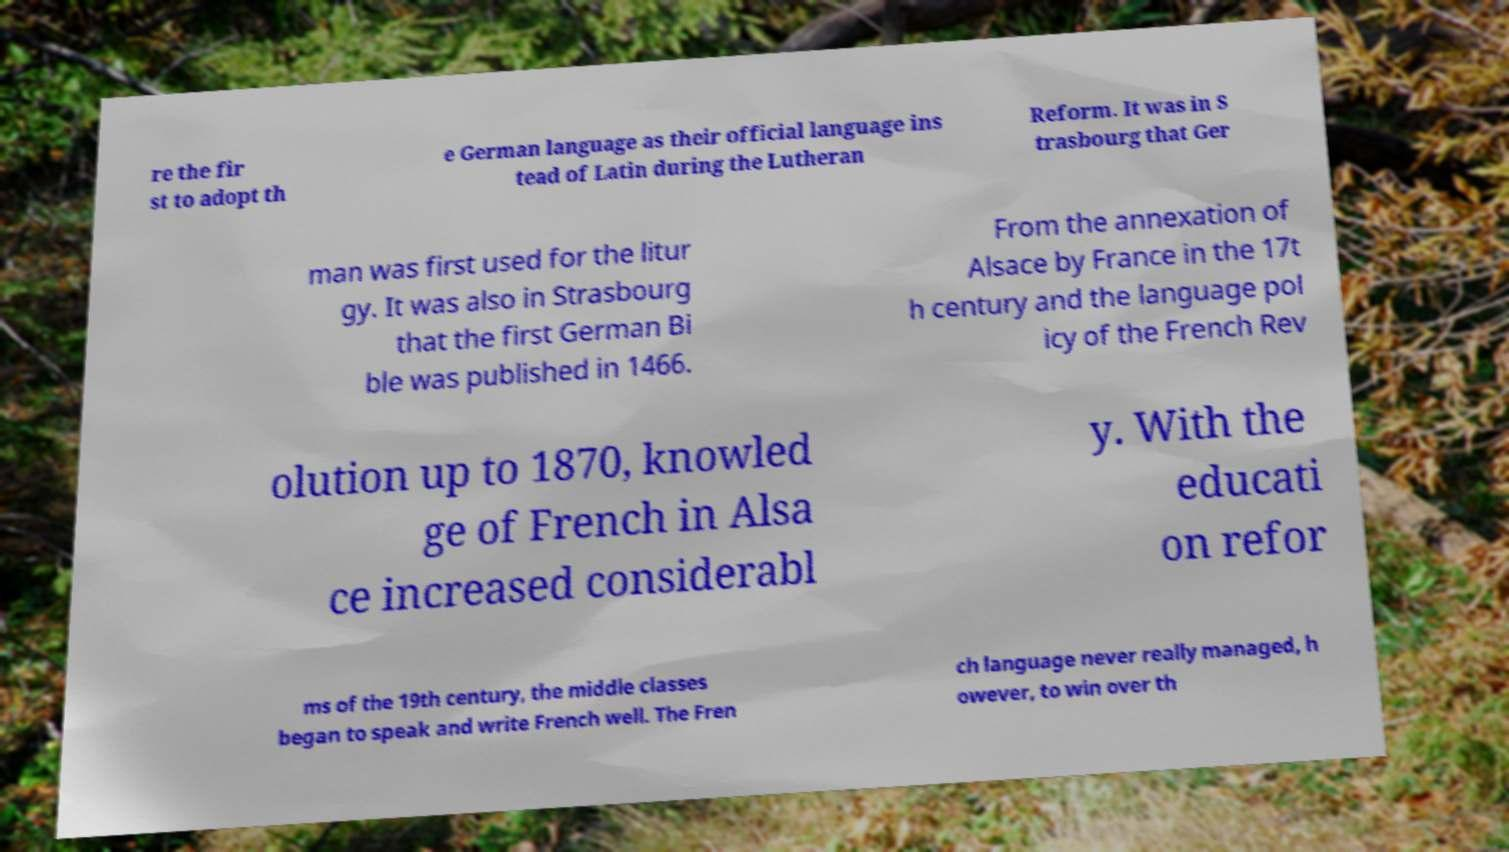Please read and relay the text visible in this image. What does it say? re the fir st to adopt th e German language as their official language ins tead of Latin during the Lutheran Reform. It was in S trasbourg that Ger man was first used for the litur gy. It was also in Strasbourg that the first German Bi ble was published in 1466. From the annexation of Alsace by France in the 17t h century and the language pol icy of the French Rev olution up to 1870, knowled ge of French in Alsa ce increased considerabl y. With the educati on refor ms of the 19th century, the middle classes began to speak and write French well. The Fren ch language never really managed, h owever, to win over th 